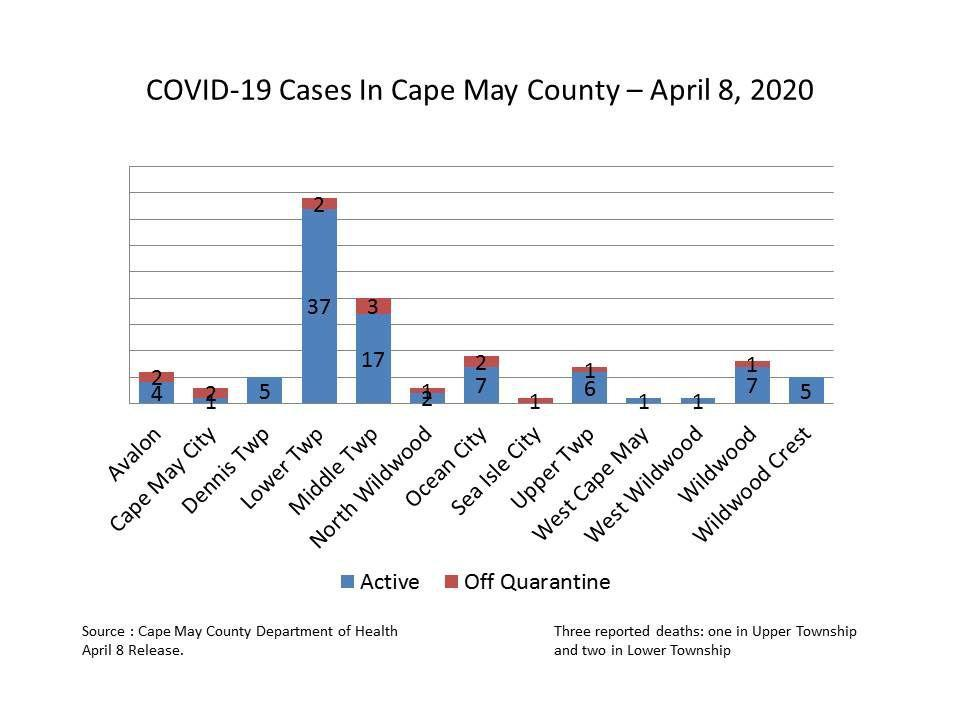What is the number of active COVID-19 cases reported in Cape May City as of April 8, 2020?
Answer the question with a short phrase. 1 What is the number of active COVID-19 cases reported in Ocean City as of April 8, 2020? 7 How many  Covid-19 cases in the Wildwood were off quarantine as of April 8, 2020? 1 What is the number of active COVID-19 cases reported in the Lower Township as of April 8, 2020? 37 How many Covid-19 cases in the Middle Township were off quarantine as of April 8, 2020? 3 